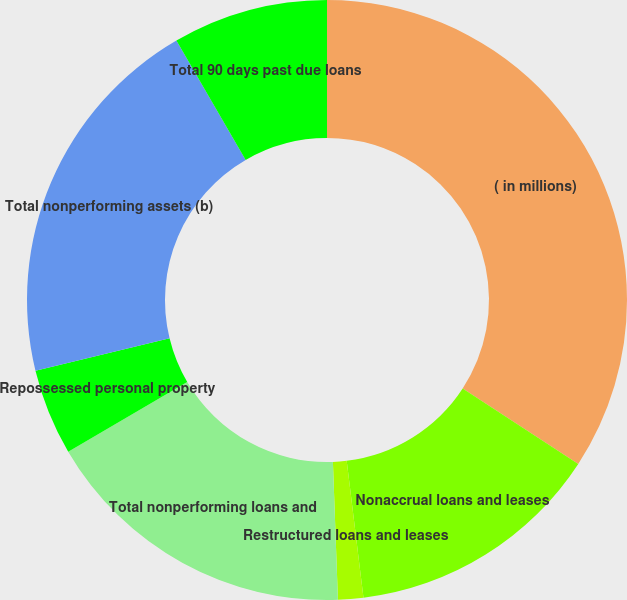<chart> <loc_0><loc_0><loc_500><loc_500><pie_chart><fcel>( in millions)<fcel>Nonaccrual loans and leases<fcel>Restructured loans and leases<fcel>Total nonperforming loans and<fcel>Repossessed personal property<fcel>Total nonperforming assets (b)<fcel>Total 90 days past due loans<nl><fcel>34.2%<fcel>13.86%<fcel>1.36%<fcel>17.14%<fcel>4.65%<fcel>20.42%<fcel>8.37%<nl></chart> 